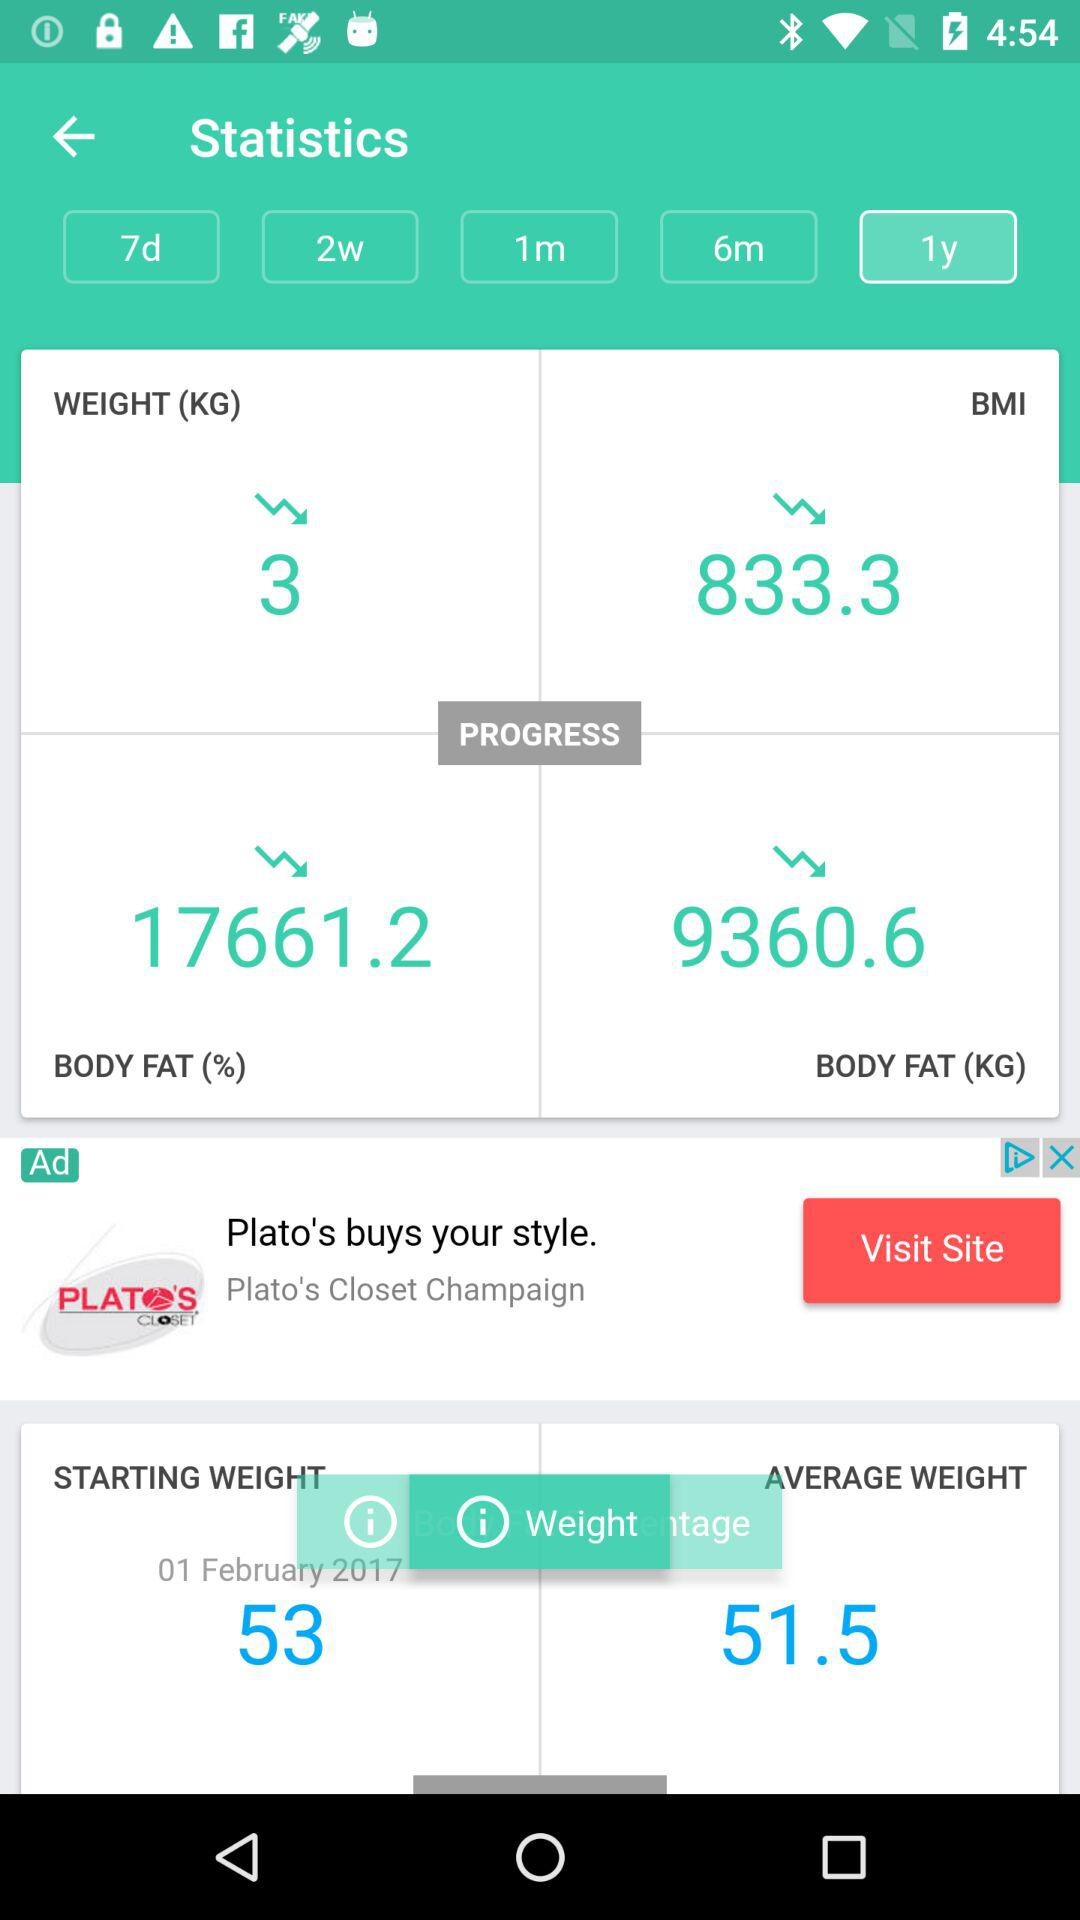What is the average weight? The average weight is 51.5. 